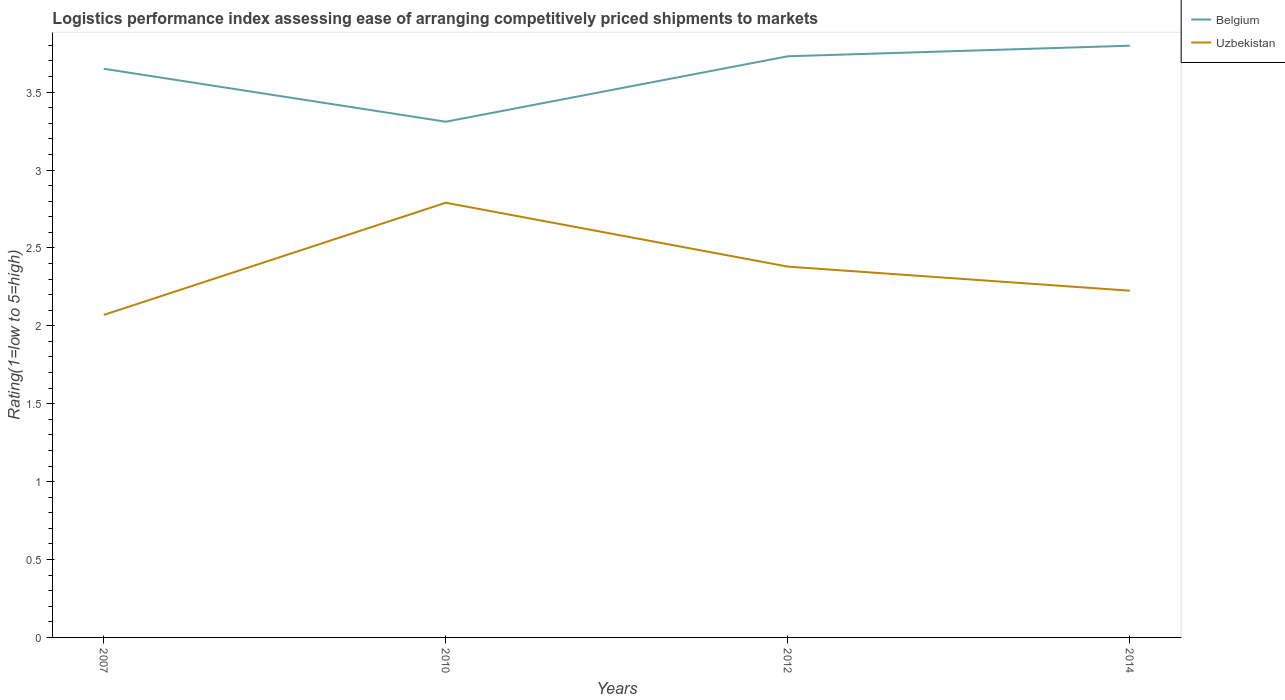How many different coloured lines are there?
Keep it short and to the point. 2. Does the line corresponding to Uzbekistan intersect with the line corresponding to Belgium?
Offer a very short reply. No. Across all years, what is the maximum Logistic performance index in Uzbekistan?
Give a very brief answer. 2.07. In which year was the Logistic performance index in Belgium maximum?
Your response must be concise. 2010. What is the total Logistic performance index in Belgium in the graph?
Provide a short and direct response. -0.08. What is the difference between the highest and the second highest Logistic performance index in Uzbekistan?
Your answer should be compact. 0.72. What is the difference between the highest and the lowest Logistic performance index in Belgium?
Your answer should be compact. 3. How many lines are there?
Your answer should be very brief. 2. How many years are there in the graph?
Give a very brief answer. 4. What is the difference between two consecutive major ticks on the Y-axis?
Your answer should be very brief. 0.5. Does the graph contain grids?
Your answer should be compact. No. Where does the legend appear in the graph?
Your answer should be very brief. Top right. How are the legend labels stacked?
Provide a short and direct response. Vertical. What is the title of the graph?
Keep it short and to the point. Logistics performance index assessing ease of arranging competitively priced shipments to markets. What is the label or title of the X-axis?
Offer a terse response. Years. What is the label or title of the Y-axis?
Make the answer very short. Rating(1=low to 5=high). What is the Rating(1=low to 5=high) of Belgium in 2007?
Offer a very short reply. 3.65. What is the Rating(1=low to 5=high) in Uzbekistan in 2007?
Provide a succinct answer. 2.07. What is the Rating(1=low to 5=high) of Belgium in 2010?
Your answer should be very brief. 3.31. What is the Rating(1=low to 5=high) in Uzbekistan in 2010?
Ensure brevity in your answer.  2.79. What is the Rating(1=low to 5=high) of Belgium in 2012?
Ensure brevity in your answer.  3.73. What is the Rating(1=low to 5=high) in Uzbekistan in 2012?
Keep it short and to the point. 2.38. What is the Rating(1=low to 5=high) of Belgium in 2014?
Keep it short and to the point. 3.8. What is the Rating(1=low to 5=high) in Uzbekistan in 2014?
Provide a succinct answer. 2.23. Across all years, what is the maximum Rating(1=low to 5=high) in Belgium?
Ensure brevity in your answer.  3.8. Across all years, what is the maximum Rating(1=low to 5=high) in Uzbekistan?
Ensure brevity in your answer.  2.79. Across all years, what is the minimum Rating(1=low to 5=high) in Belgium?
Offer a very short reply. 3.31. Across all years, what is the minimum Rating(1=low to 5=high) of Uzbekistan?
Offer a terse response. 2.07. What is the total Rating(1=low to 5=high) of Belgium in the graph?
Your answer should be very brief. 14.49. What is the total Rating(1=low to 5=high) in Uzbekistan in the graph?
Keep it short and to the point. 9.47. What is the difference between the Rating(1=low to 5=high) in Belgium in 2007 and that in 2010?
Make the answer very short. 0.34. What is the difference between the Rating(1=low to 5=high) of Uzbekistan in 2007 and that in 2010?
Offer a terse response. -0.72. What is the difference between the Rating(1=low to 5=high) in Belgium in 2007 and that in 2012?
Your answer should be very brief. -0.08. What is the difference between the Rating(1=low to 5=high) of Uzbekistan in 2007 and that in 2012?
Your response must be concise. -0.31. What is the difference between the Rating(1=low to 5=high) in Belgium in 2007 and that in 2014?
Provide a short and direct response. -0.15. What is the difference between the Rating(1=low to 5=high) of Uzbekistan in 2007 and that in 2014?
Make the answer very short. -0.16. What is the difference between the Rating(1=low to 5=high) in Belgium in 2010 and that in 2012?
Provide a short and direct response. -0.42. What is the difference between the Rating(1=low to 5=high) in Uzbekistan in 2010 and that in 2012?
Give a very brief answer. 0.41. What is the difference between the Rating(1=low to 5=high) in Belgium in 2010 and that in 2014?
Provide a succinct answer. -0.49. What is the difference between the Rating(1=low to 5=high) in Uzbekistan in 2010 and that in 2014?
Your response must be concise. 0.56. What is the difference between the Rating(1=low to 5=high) of Belgium in 2012 and that in 2014?
Ensure brevity in your answer.  -0.07. What is the difference between the Rating(1=low to 5=high) of Uzbekistan in 2012 and that in 2014?
Make the answer very short. 0.15. What is the difference between the Rating(1=low to 5=high) of Belgium in 2007 and the Rating(1=low to 5=high) of Uzbekistan in 2010?
Make the answer very short. 0.86. What is the difference between the Rating(1=low to 5=high) of Belgium in 2007 and the Rating(1=low to 5=high) of Uzbekistan in 2012?
Keep it short and to the point. 1.27. What is the difference between the Rating(1=low to 5=high) of Belgium in 2007 and the Rating(1=low to 5=high) of Uzbekistan in 2014?
Your answer should be very brief. 1.42. What is the difference between the Rating(1=low to 5=high) in Belgium in 2010 and the Rating(1=low to 5=high) in Uzbekistan in 2014?
Make the answer very short. 1.08. What is the difference between the Rating(1=low to 5=high) of Belgium in 2012 and the Rating(1=low to 5=high) of Uzbekistan in 2014?
Offer a very short reply. 1.5. What is the average Rating(1=low to 5=high) in Belgium per year?
Provide a short and direct response. 3.62. What is the average Rating(1=low to 5=high) of Uzbekistan per year?
Ensure brevity in your answer.  2.37. In the year 2007, what is the difference between the Rating(1=low to 5=high) of Belgium and Rating(1=low to 5=high) of Uzbekistan?
Your answer should be very brief. 1.58. In the year 2010, what is the difference between the Rating(1=low to 5=high) in Belgium and Rating(1=low to 5=high) in Uzbekistan?
Your response must be concise. 0.52. In the year 2012, what is the difference between the Rating(1=low to 5=high) in Belgium and Rating(1=low to 5=high) in Uzbekistan?
Make the answer very short. 1.35. In the year 2014, what is the difference between the Rating(1=low to 5=high) in Belgium and Rating(1=low to 5=high) in Uzbekistan?
Give a very brief answer. 1.57. What is the ratio of the Rating(1=low to 5=high) in Belgium in 2007 to that in 2010?
Make the answer very short. 1.1. What is the ratio of the Rating(1=low to 5=high) of Uzbekistan in 2007 to that in 2010?
Offer a terse response. 0.74. What is the ratio of the Rating(1=low to 5=high) in Belgium in 2007 to that in 2012?
Give a very brief answer. 0.98. What is the ratio of the Rating(1=low to 5=high) in Uzbekistan in 2007 to that in 2012?
Provide a short and direct response. 0.87. What is the ratio of the Rating(1=low to 5=high) of Belgium in 2007 to that in 2014?
Keep it short and to the point. 0.96. What is the ratio of the Rating(1=low to 5=high) of Uzbekistan in 2007 to that in 2014?
Your answer should be very brief. 0.93. What is the ratio of the Rating(1=low to 5=high) of Belgium in 2010 to that in 2012?
Provide a succinct answer. 0.89. What is the ratio of the Rating(1=low to 5=high) of Uzbekistan in 2010 to that in 2012?
Your answer should be compact. 1.17. What is the ratio of the Rating(1=low to 5=high) in Belgium in 2010 to that in 2014?
Your answer should be very brief. 0.87. What is the ratio of the Rating(1=low to 5=high) in Uzbekistan in 2010 to that in 2014?
Make the answer very short. 1.25. What is the ratio of the Rating(1=low to 5=high) in Belgium in 2012 to that in 2014?
Keep it short and to the point. 0.98. What is the ratio of the Rating(1=low to 5=high) of Uzbekistan in 2012 to that in 2014?
Offer a terse response. 1.07. What is the difference between the highest and the second highest Rating(1=low to 5=high) of Belgium?
Keep it short and to the point. 0.07. What is the difference between the highest and the second highest Rating(1=low to 5=high) in Uzbekistan?
Give a very brief answer. 0.41. What is the difference between the highest and the lowest Rating(1=low to 5=high) in Belgium?
Ensure brevity in your answer.  0.49. What is the difference between the highest and the lowest Rating(1=low to 5=high) in Uzbekistan?
Offer a terse response. 0.72. 